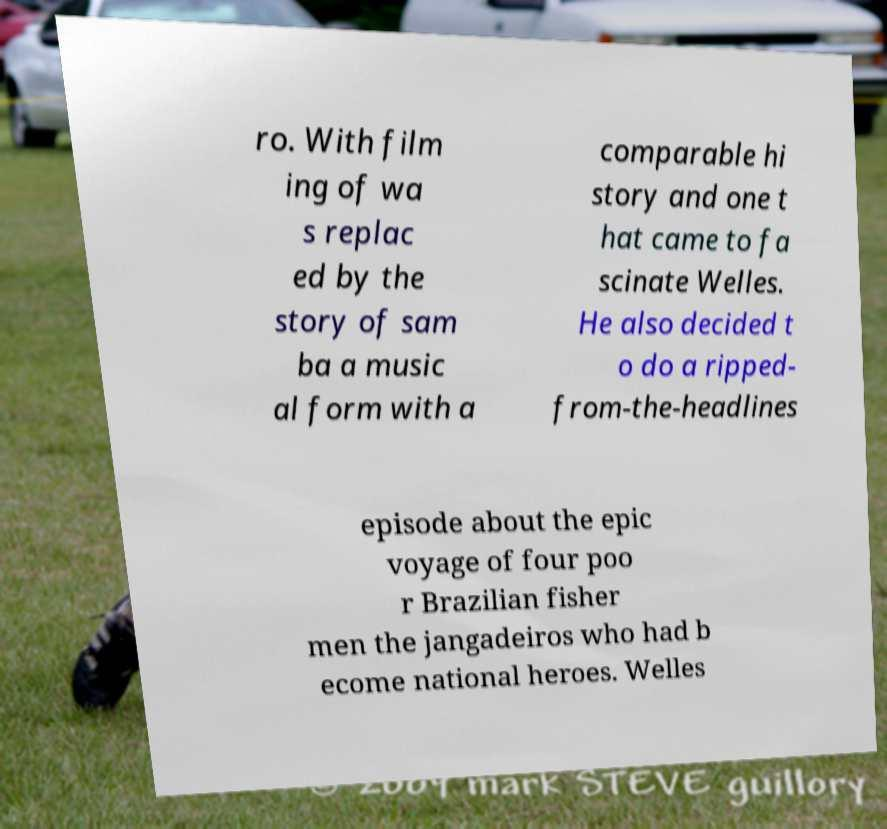Please read and relay the text visible in this image. What does it say? ro. With film ing of wa s replac ed by the story of sam ba a music al form with a comparable hi story and one t hat came to fa scinate Welles. He also decided t o do a ripped- from-the-headlines episode about the epic voyage of four poo r Brazilian fisher men the jangadeiros who had b ecome national heroes. Welles 